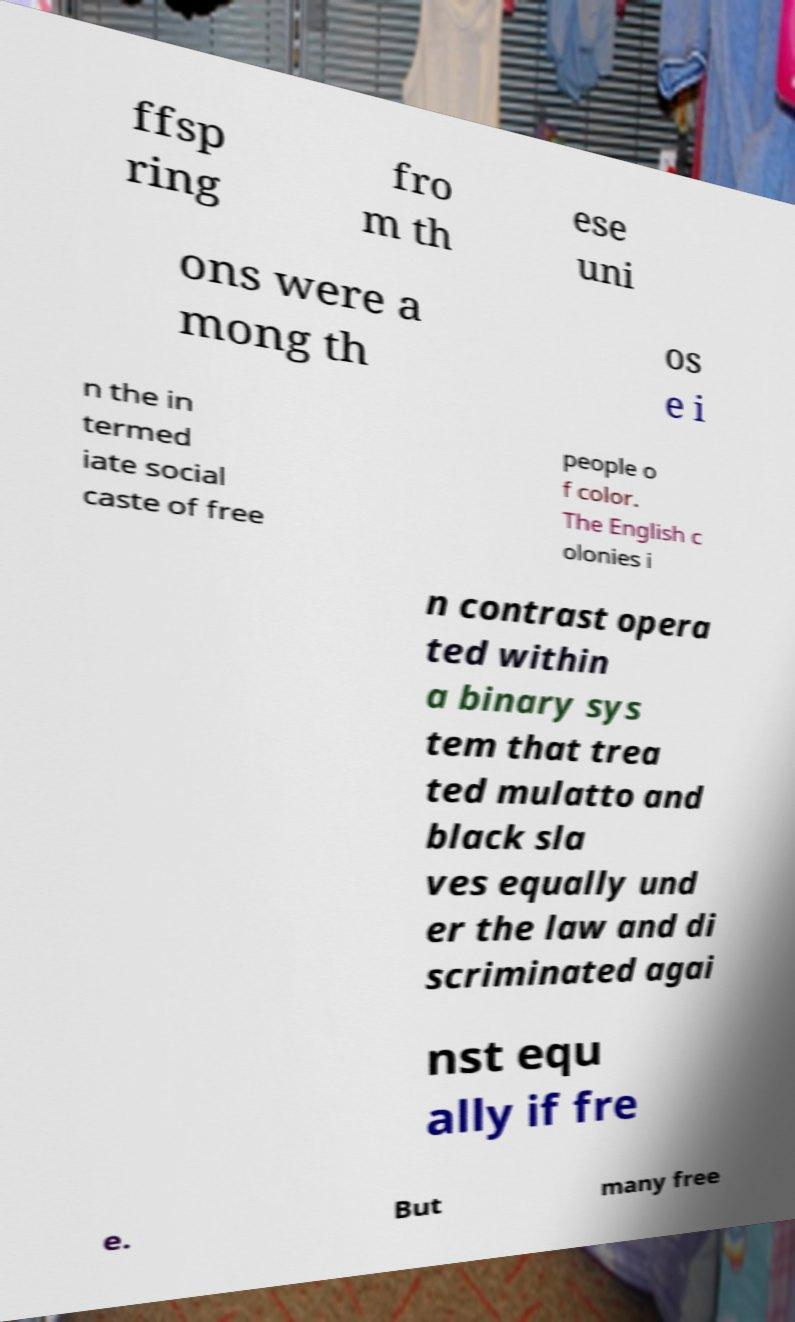There's text embedded in this image that I need extracted. Can you transcribe it verbatim? ffsp ring fro m th ese uni ons were a mong th os e i n the in termed iate social caste of free people o f color. The English c olonies i n contrast opera ted within a binary sys tem that trea ted mulatto and black sla ves equally und er the law and di scriminated agai nst equ ally if fre e. But many free 